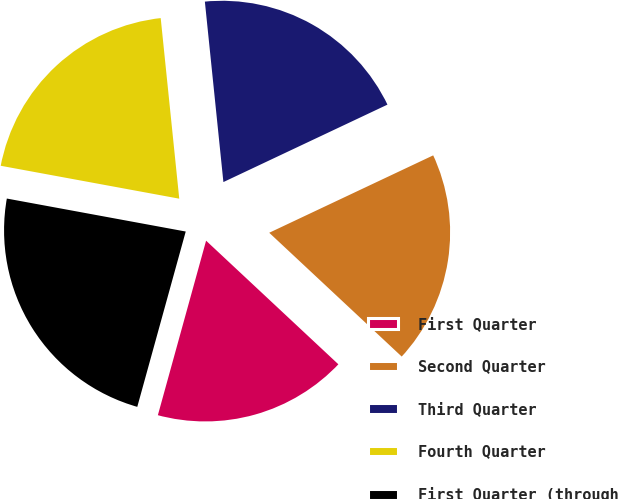Convert chart. <chart><loc_0><loc_0><loc_500><loc_500><pie_chart><fcel>First Quarter<fcel>Second Quarter<fcel>Third Quarter<fcel>Fourth Quarter<fcel>First Quarter (through<nl><fcel>17.33%<fcel>18.98%<fcel>19.61%<fcel>20.47%<fcel>23.61%<nl></chart> 